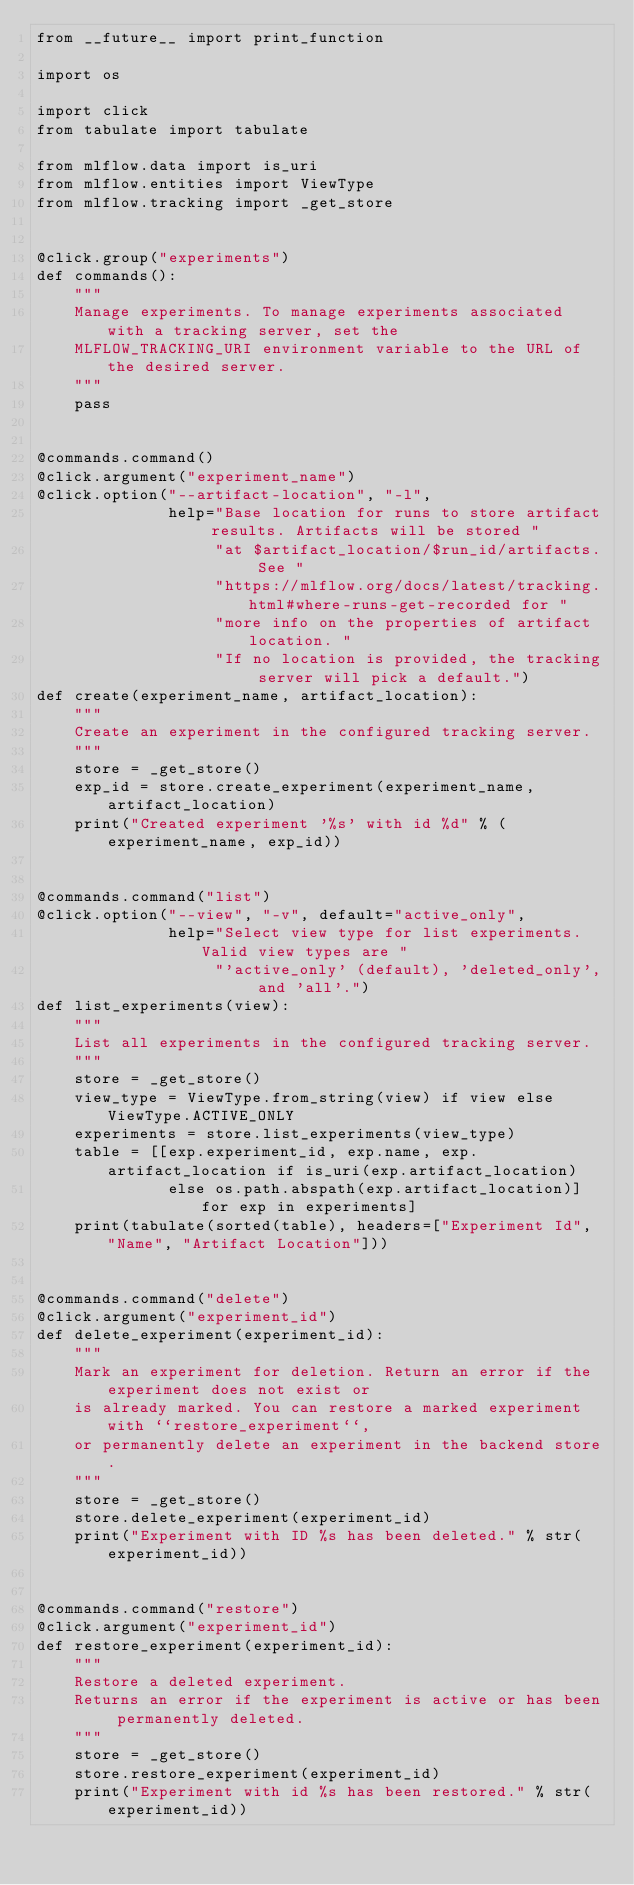Convert code to text. <code><loc_0><loc_0><loc_500><loc_500><_Python_>from __future__ import print_function

import os

import click
from tabulate import tabulate

from mlflow.data import is_uri
from mlflow.entities import ViewType
from mlflow.tracking import _get_store


@click.group("experiments")
def commands():
    """
    Manage experiments. To manage experiments associated with a tracking server, set the
    MLFLOW_TRACKING_URI environment variable to the URL of the desired server.
    """
    pass


@commands.command()
@click.argument("experiment_name")
@click.option("--artifact-location", "-l",
              help="Base location for runs to store artifact results. Artifacts will be stored "
                   "at $artifact_location/$run_id/artifacts. See "
                   "https://mlflow.org/docs/latest/tracking.html#where-runs-get-recorded for "
                   "more info on the properties of artifact location. "
                   "If no location is provided, the tracking server will pick a default.")
def create(experiment_name, artifact_location):
    """
    Create an experiment in the configured tracking server.
    """
    store = _get_store()
    exp_id = store.create_experiment(experiment_name, artifact_location)
    print("Created experiment '%s' with id %d" % (experiment_name, exp_id))


@commands.command("list")
@click.option("--view", "-v", default="active_only",
              help="Select view type for list experiments. Valid view types are "
                   "'active_only' (default), 'deleted_only', and 'all'.")
def list_experiments(view):
    """
    List all experiments in the configured tracking server.
    """
    store = _get_store()
    view_type = ViewType.from_string(view) if view else ViewType.ACTIVE_ONLY
    experiments = store.list_experiments(view_type)
    table = [[exp.experiment_id, exp.name, exp.artifact_location if is_uri(exp.artifact_location)
              else os.path.abspath(exp.artifact_location)] for exp in experiments]
    print(tabulate(sorted(table), headers=["Experiment Id", "Name", "Artifact Location"]))


@commands.command("delete")
@click.argument("experiment_id")
def delete_experiment(experiment_id):
    """
    Mark an experiment for deletion. Return an error if the experiment does not exist or
    is already marked. You can restore a marked experiment with ``restore_experiment``,
    or permanently delete an experiment in the backend store.
    """
    store = _get_store()
    store.delete_experiment(experiment_id)
    print("Experiment with ID %s has been deleted." % str(experiment_id))


@commands.command("restore")
@click.argument("experiment_id")
def restore_experiment(experiment_id):
    """
    Restore a deleted experiment.
    Returns an error if the experiment is active or has been permanently deleted.
    """
    store = _get_store()
    store.restore_experiment(experiment_id)
    print("Experiment with id %s has been restored." % str(experiment_id))
</code> 